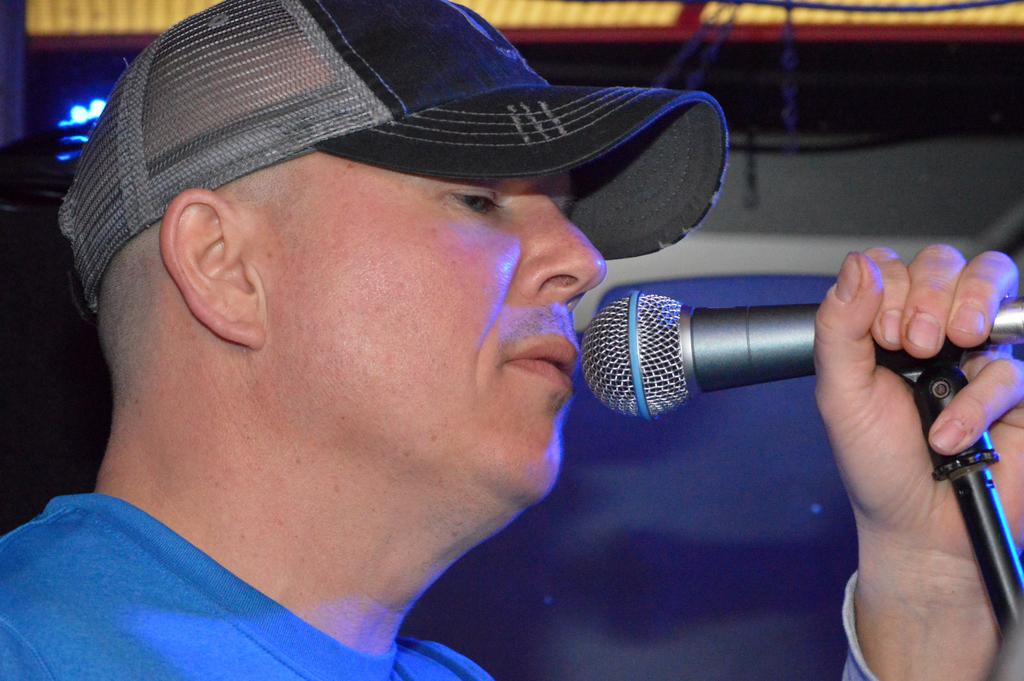What is the main subject of the image? There is a man in the image. What is the man holding in the image? The man is holding a microphone. Can you describe the man's attire in the image? The man is wearing a cap. What type of scent can be detected from the man in the image? There is no information about the scent of the man in the image, so it cannot be determined. 